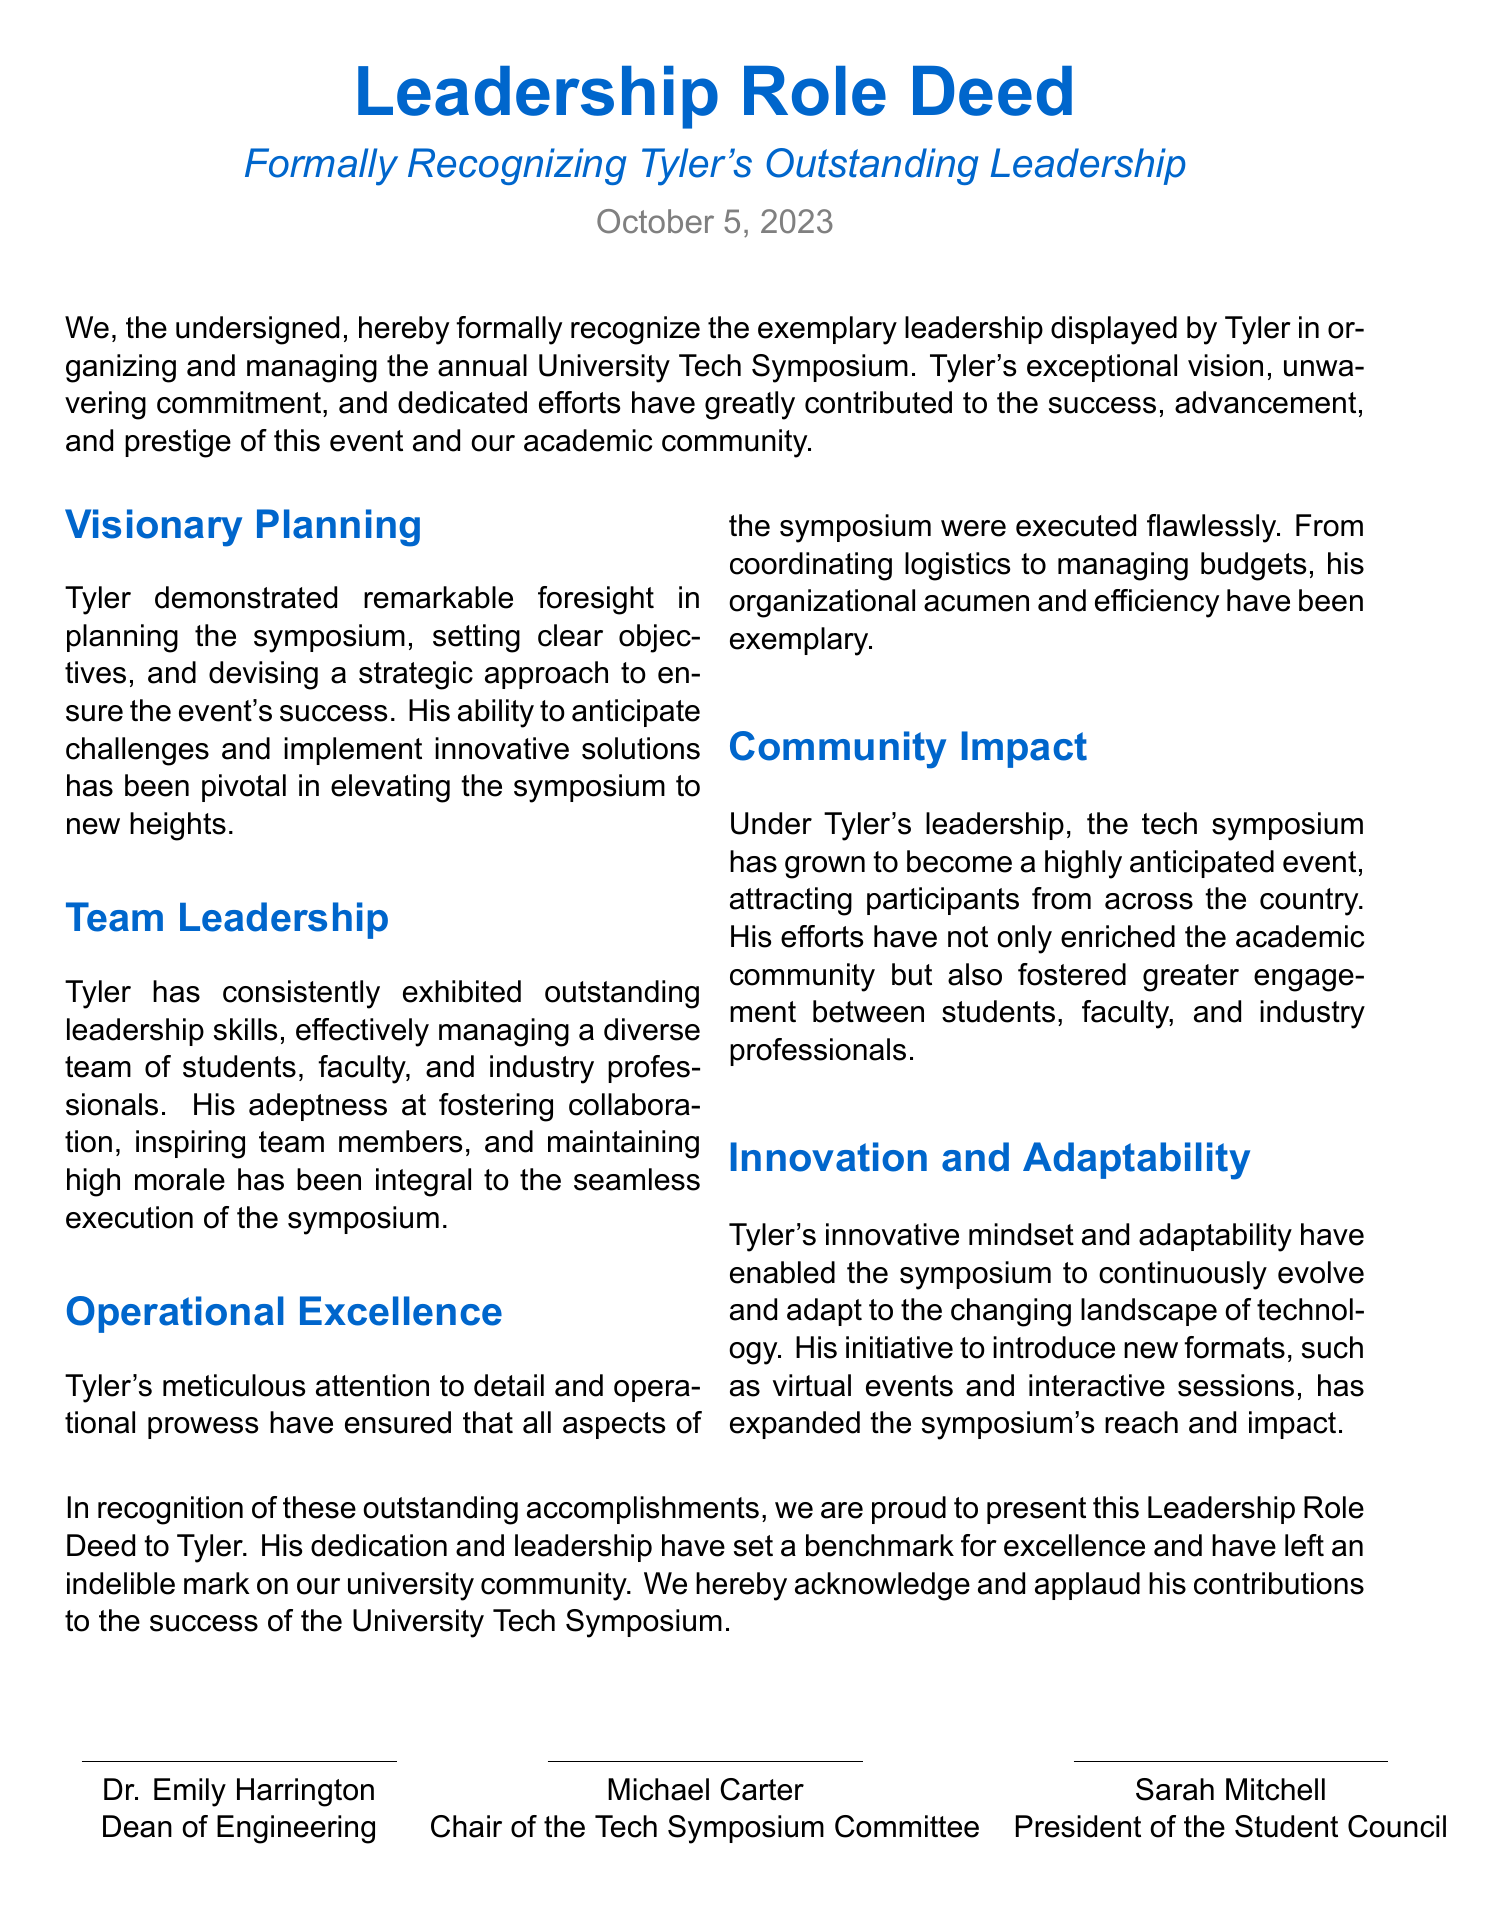What is the title of the document? The title is the formal designation of the document, which includes the recognition of Tyler's leadership.
Answer: Leadership Role Deed Who is the recipient of the recognition? The recognition formally acknowledges Tyler for his achievements in leadership.
Answer: Tyler What date is mentioned on the document? The date signifies when the recognition was formally issued and is October 5, 2023.
Answer: October 5, 2023 What type of event did Tyler organize? The specific event for which Tyler is recognized is detailed in the document.
Answer: University Tech Symposium Who is the Dean of Engineering as per the document? The document lists one of the signatories with their title, providing their name and position.
Answer: Dr. Emily Harrington What is highlighted as one of Tyler's exceptional qualities in team management? The document emphasizes certain attributes of Tyler's leadership style in managing peers.
Answer: Fostering collaboration What has been the impact of the symposium under Tyler's leadership? The document notes the broader effects of the event on the academic community they operate in.
Answer: Community impact Which innovative aspect did Tyler introduce to the symposium? The document describes how Tyler facilitated improvements in the event structure, showcasing his leadership.
Answer: Virtual events What is the purpose of this Deed? The purpose is explicitly mentioned as a formal recognition of accomplishments in leadership.
Answer: To formally recognize leadership 